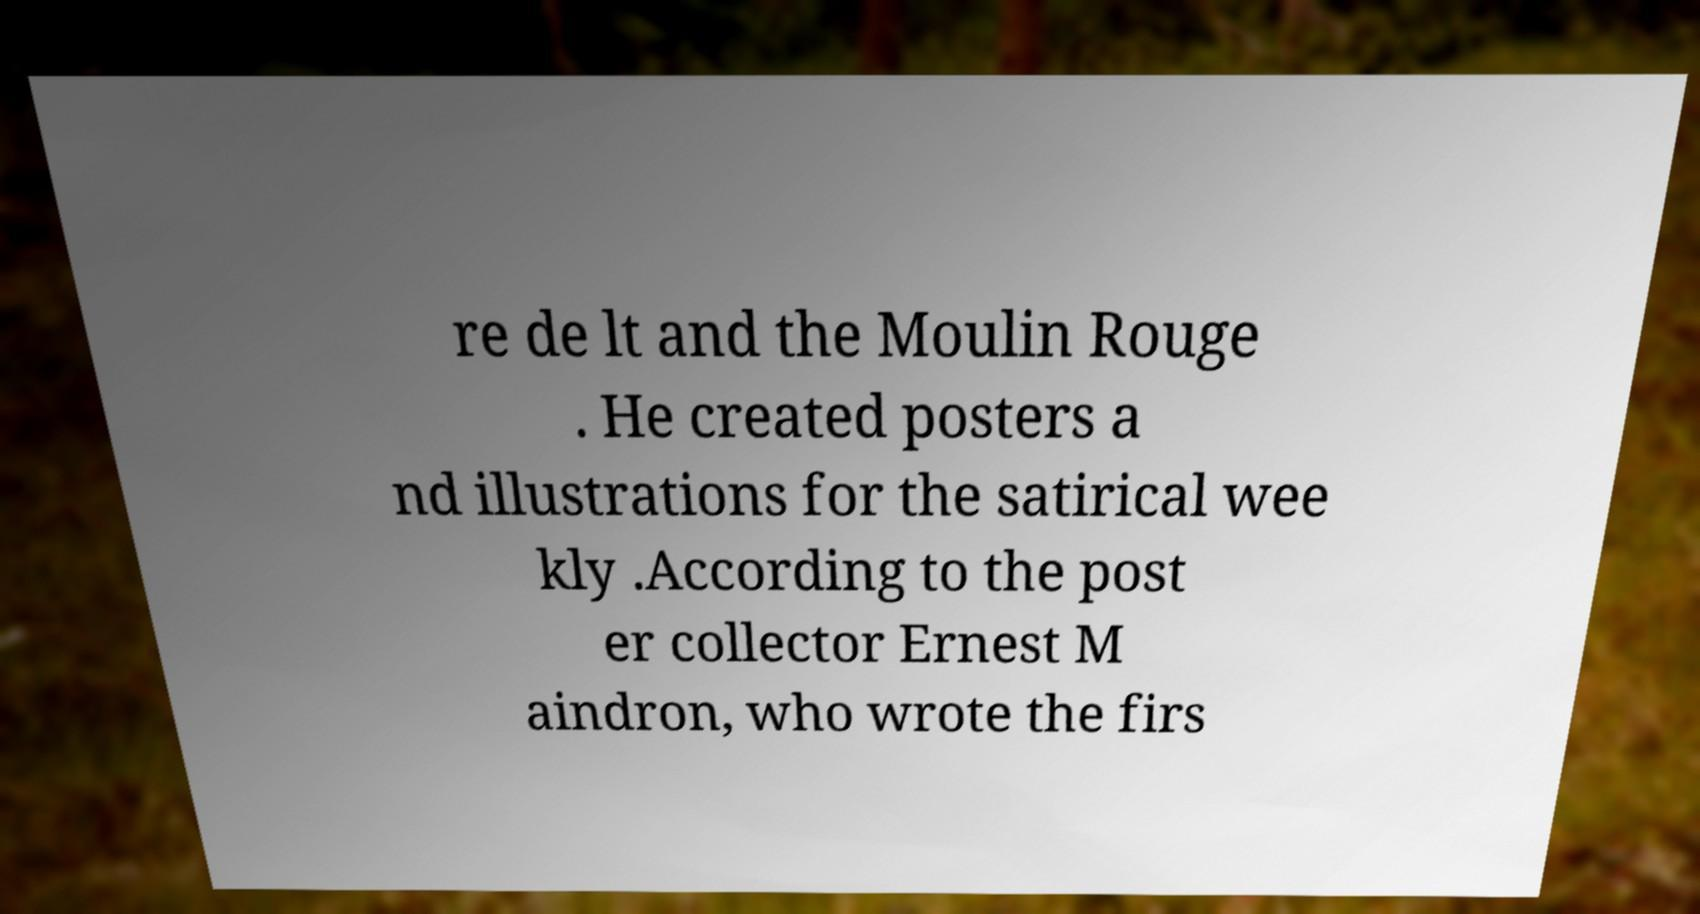Please read and relay the text visible in this image. What does it say? re de lt and the Moulin Rouge . He created posters a nd illustrations for the satirical wee kly .According to the post er collector Ernest M aindron, who wrote the firs 